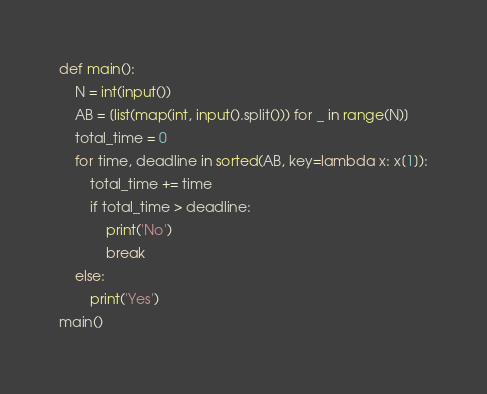<code> <loc_0><loc_0><loc_500><loc_500><_Python_>def main():
    N = int(input())
    AB = [list(map(int, input().split())) for _ in range(N)]
    total_time = 0
    for time, deadline in sorted(AB, key=lambda x: x[1]):
        total_time += time
        if total_time > deadline:
            print('No')
            break
    else:
        print('Yes')
main()</code> 